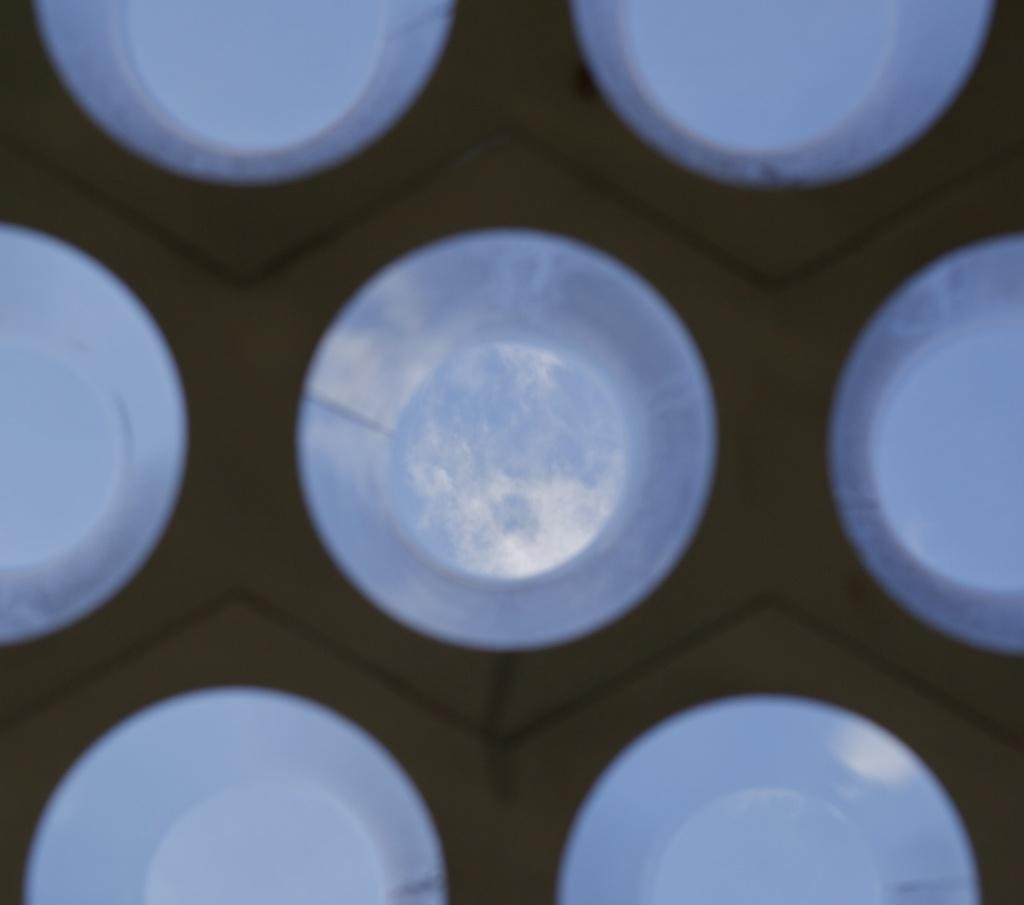What is the primary color of the surface in the image? The primary color of the surface in the image is brown. What shapes can be seen on the surface? There are white color circles on the surface. What type of drug is being used by the astronauts in the image? There is no mention of astronauts or drugs in the image. The image contains a brown surface with white circles. 